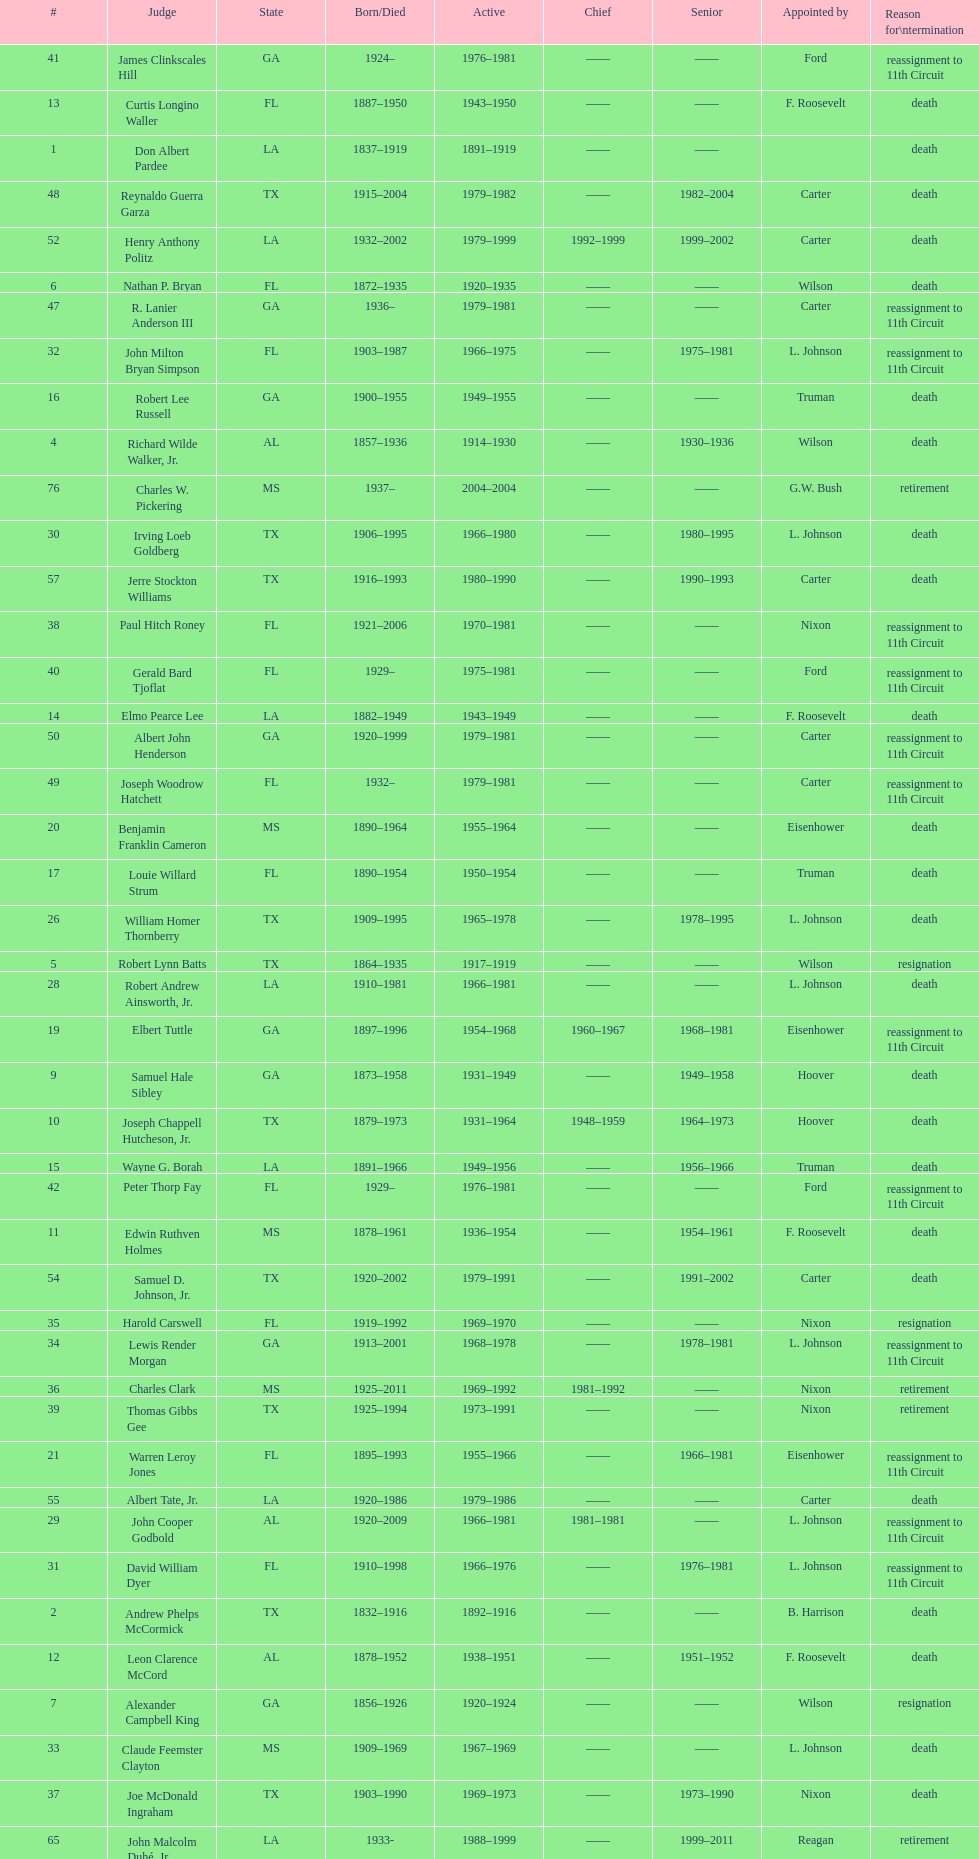Which judge was last appointed by president truman? Richard Rives. 